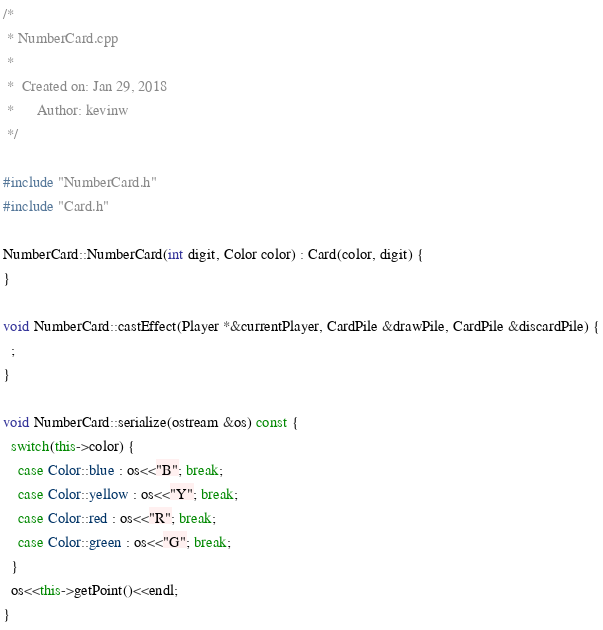<code> <loc_0><loc_0><loc_500><loc_500><_C++_>/*
 * NumberCard.cpp
 *
 *  Created on: Jan 29, 2018
 *      Author: kevinw
 */

#include "NumberCard.h"
#include "Card.h"

NumberCard::NumberCard(int digit, Color color) : Card(color, digit) {
}

void NumberCard::castEffect(Player *&currentPlayer, CardPile &drawPile, CardPile &discardPile) {
  ;
}

void NumberCard::serialize(ostream &os) const {
  switch(this->color) {
    case Color::blue : os<<"B"; break;
    case Color::yellow : os<<"Y"; break;
    case Color::red : os<<"R"; break;
    case Color::green : os<<"G"; break;
  }
  os<<this->getPoint()<<endl;
}
</code> 